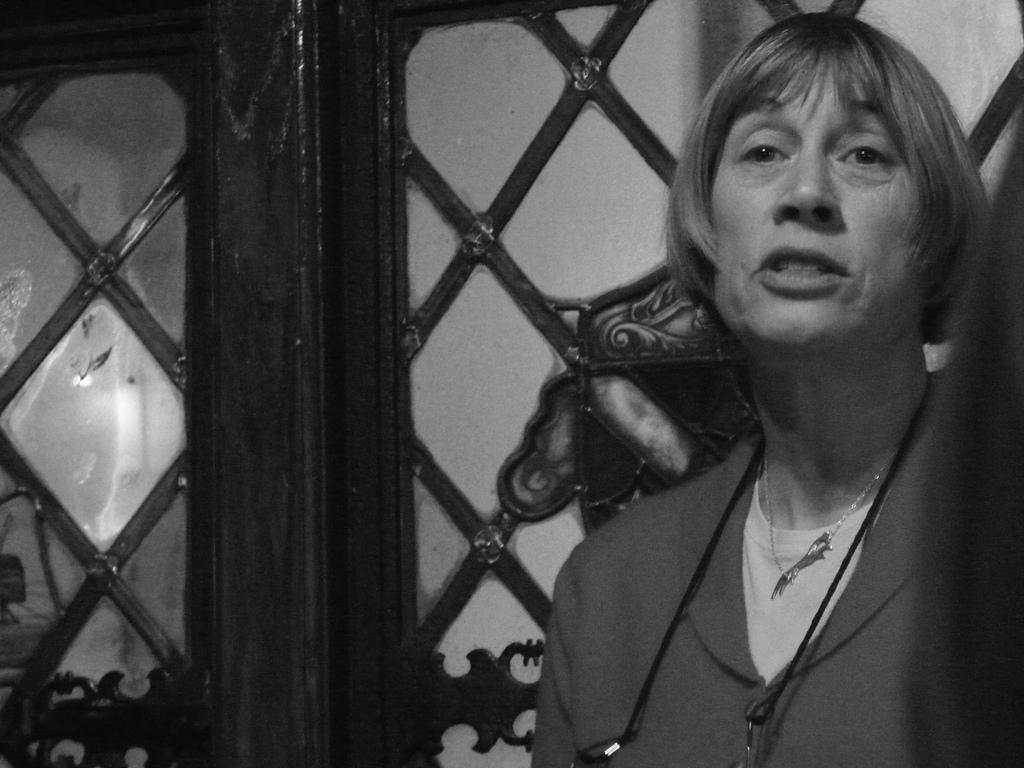Can you describe this image briefly? It is a black and white picture. On the right side of the image we can see a person in a different costume. In the background there is a door. 